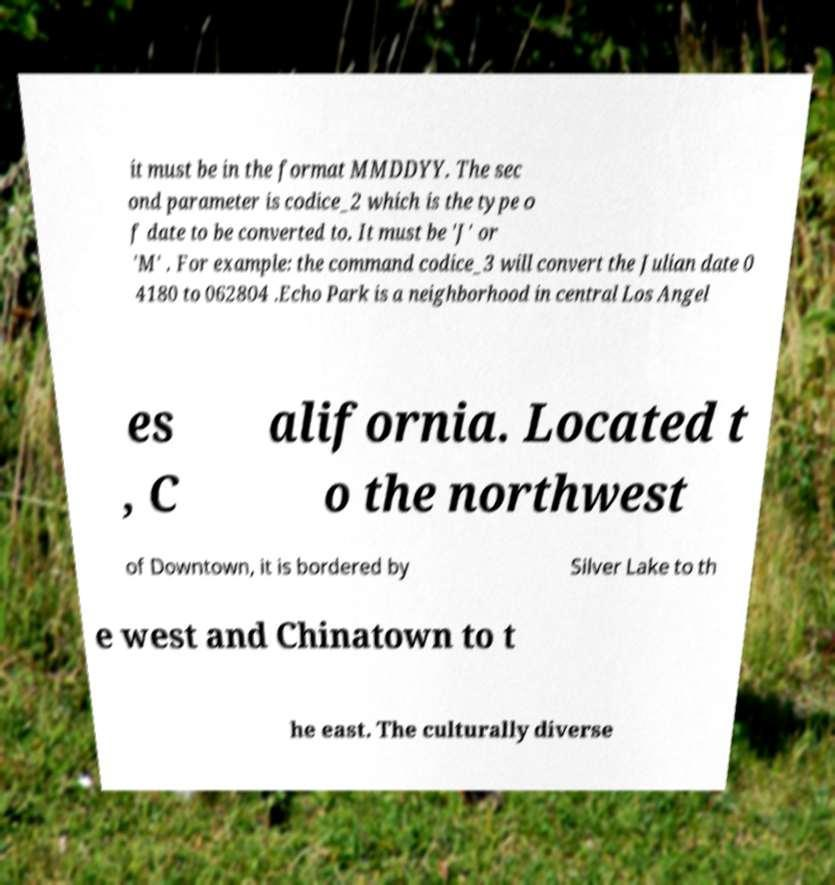What messages or text are displayed in this image? I need them in a readable, typed format. it must be in the format MMDDYY. The sec ond parameter is codice_2 which is the type o f date to be converted to. It must be 'J' or 'M' . For example: the command codice_3 will convert the Julian date 0 4180 to 062804 .Echo Park is a neighborhood in central Los Angel es , C alifornia. Located t o the northwest of Downtown, it is bordered by Silver Lake to th e west and Chinatown to t he east. The culturally diverse 